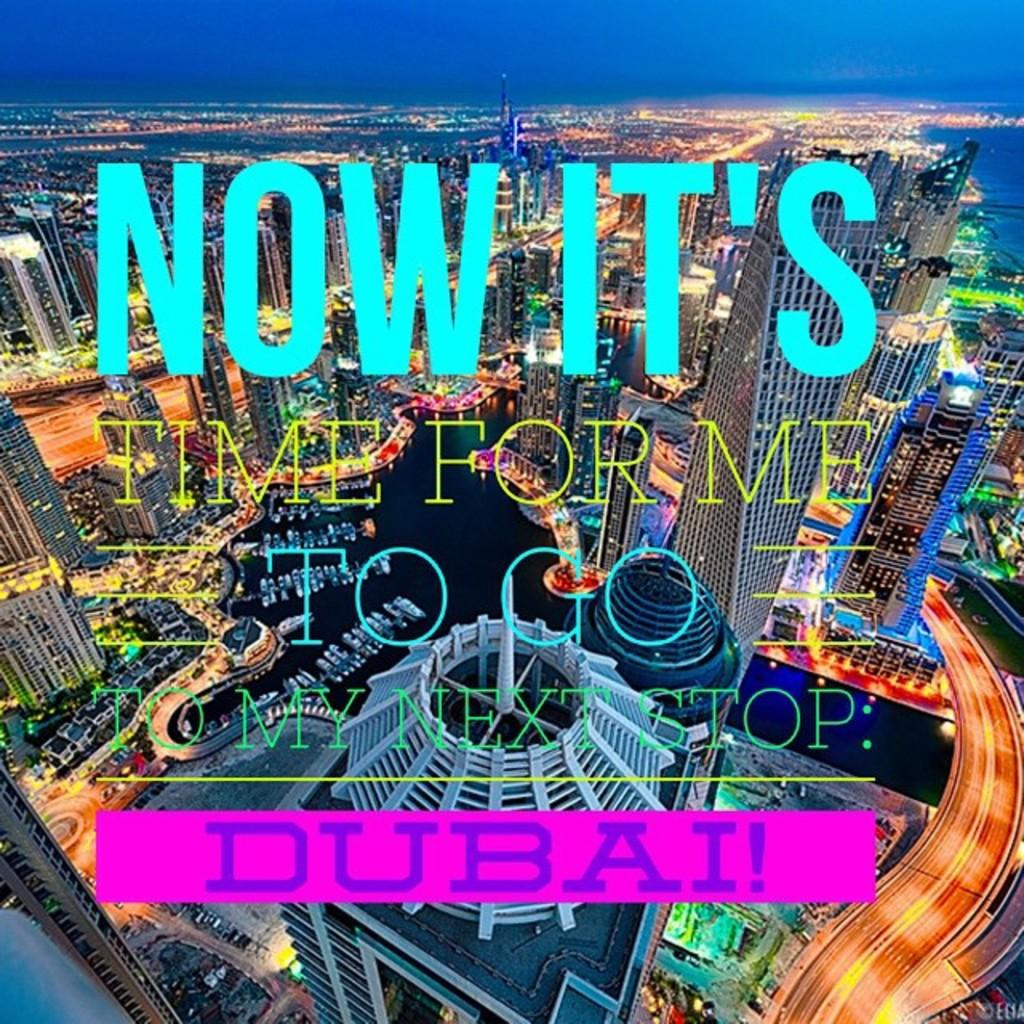What can be found in the image that contains written information? There is some text in the image. What type of structures are visible in the image? There are buildings in the image. What can be seen illuminating the scene in the image? There are lights in the image. What architectural feature is present in the image that connects two areas? There is a bridge in the image. What else can be seen in the image besides the mentioned elements? There are objects in the image. What is visible in the background of the image? The sky is visible in the background of the image. Can you tell me which letter the bridge is spelling out in the image? There is no indication that the bridge is spelling out a letter in the image. What type of toothpaste is being used to clean the objects in the image? There is no toothpaste present in the image. 